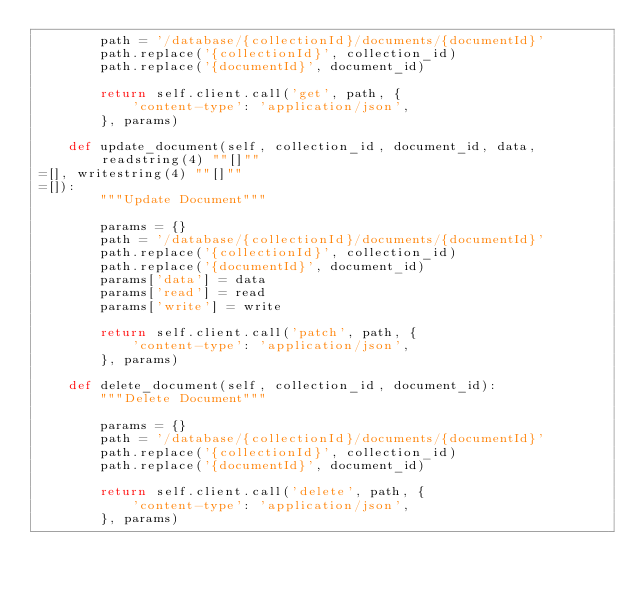<code> <loc_0><loc_0><loc_500><loc_500><_Python_>        path = '/database/{collectionId}/documents/{documentId}'
        path.replace('{collectionId}', collection_id)                
        path.replace('{documentId}', document_id)                

        return self.client.call('get', path, {
            'content-type': 'application/json',
        }, params)

    def update_document(self, collection_id, document_id, data, readstring(4) ""[]""
=[], writestring(4) ""[]""
=[]):
        """Update Document"""

        params = {}
        path = '/database/{collectionId}/documents/{documentId}'
        path.replace('{collectionId}', collection_id)                
        path.replace('{documentId}', document_id)                
        params['data'] = data
        params['read'] = read
        params['write'] = write

        return self.client.call('patch', path, {
            'content-type': 'application/json',
        }, params)

    def delete_document(self, collection_id, document_id):
        """Delete Document"""

        params = {}
        path = '/database/{collectionId}/documents/{documentId}'
        path.replace('{collectionId}', collection_id)                
        path.replace('{documentId}', document_id)                

        return self.client.call('delete', path, {
            'content-type': 'application/json',
        }, params)
</code> 